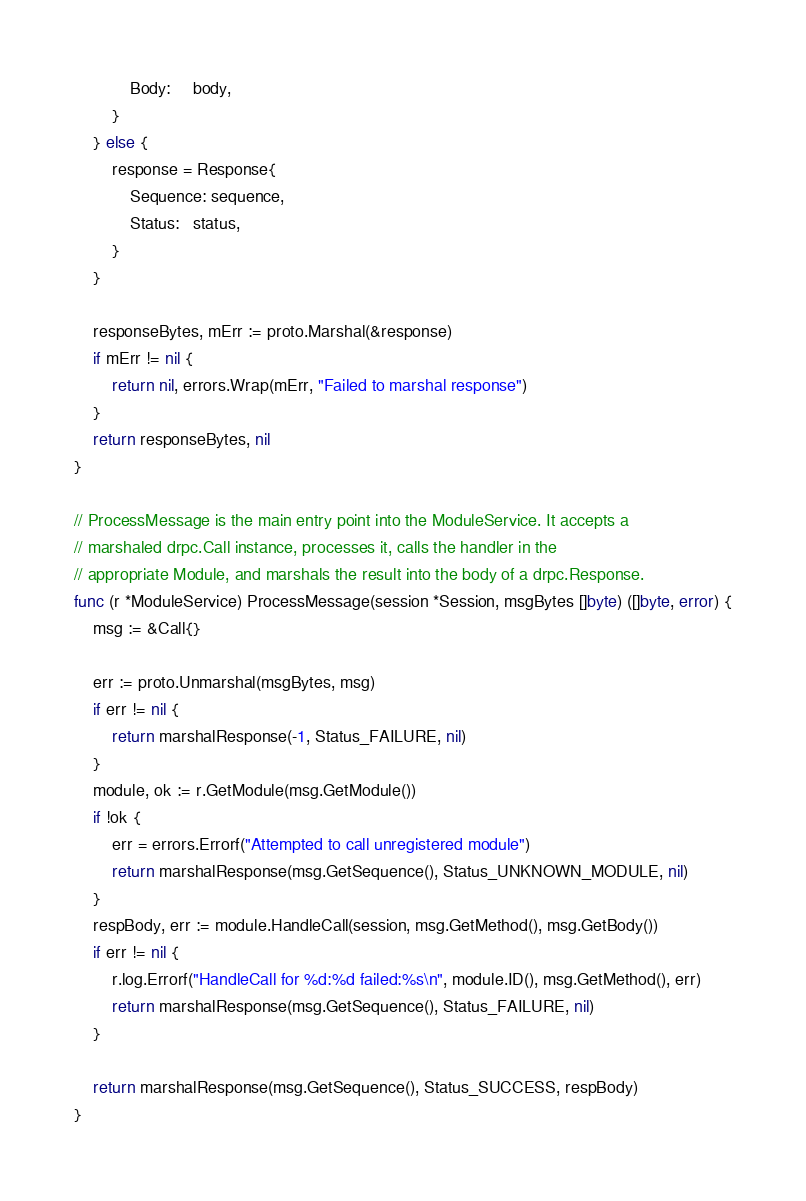Convert code to text. <code><loc_0><loc_0><loc_500><loc_500><_Go_>			Body:     body,
		}
	} else {
		response = Response{
			Sequence: sequence,
			Status:   status,
		}
	}

	responseBytes, mErr := proto.Marshal(&response)
	if mErr != nil {
		return nil, errors.Wrap(mErr, "Failed to marshal response")
	}
	return responseBytes, nil
}

// ProcessMessage is the main entry point into the ModuleService. It accepts a
// marshaled drpc.Call instance, processes it, calls the handler in the
// appropriate Module, and marshals the result into the body of a drpc.Response.
func (r *ModuleService) ProcessMessage(session *Session, msgBytes []byte) ([]byte, error) {
	msg := &Call{}

	err := proto.Unmarshal(msgBytes, msg)
	if err != nil {
		return marshalResponse(-1, Status_FAILURE, nil)
	}
	module, ok := r.GetModule(msg.GetModule())
	if !ok {
		err = errors.Errorf("Attempted to call unregistered module")
		return marshalResponse(msg.GetSequence(), Status_UNKNOWN_MODULE, nil)
	}
	respBody, err := module.HandleCall(session, msg.GetMethod(), msg.GetBody())
	if err != nil {
		r.log.Errorf("HandleCall for %d:%d failed:%s\n", module.ID(), msg.GetMethod(), err)
		return marshalResponse(msg.GetSequence(), Status_FAILURE, nil)
	}

	return marshalResponse(msg.GetSequence(), Status_SUCCESS, respBody)
}
</code> 